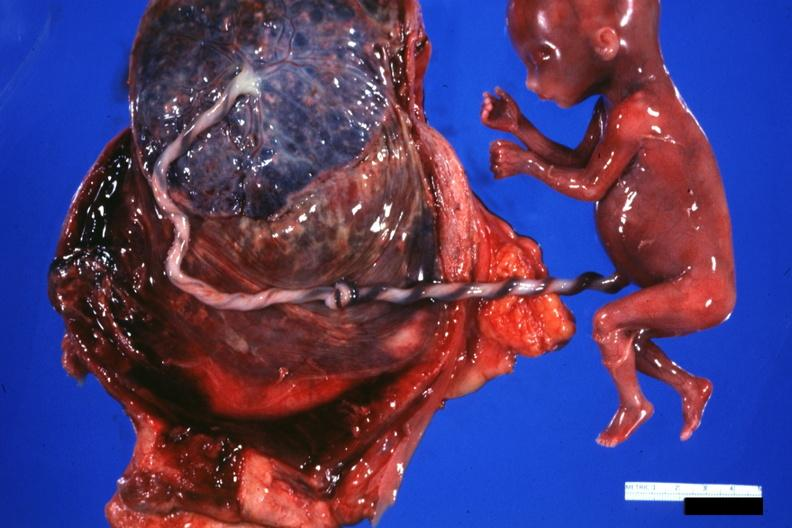where does this part belong to?
Answer the question using a single word or phrase. Female reproductive system 